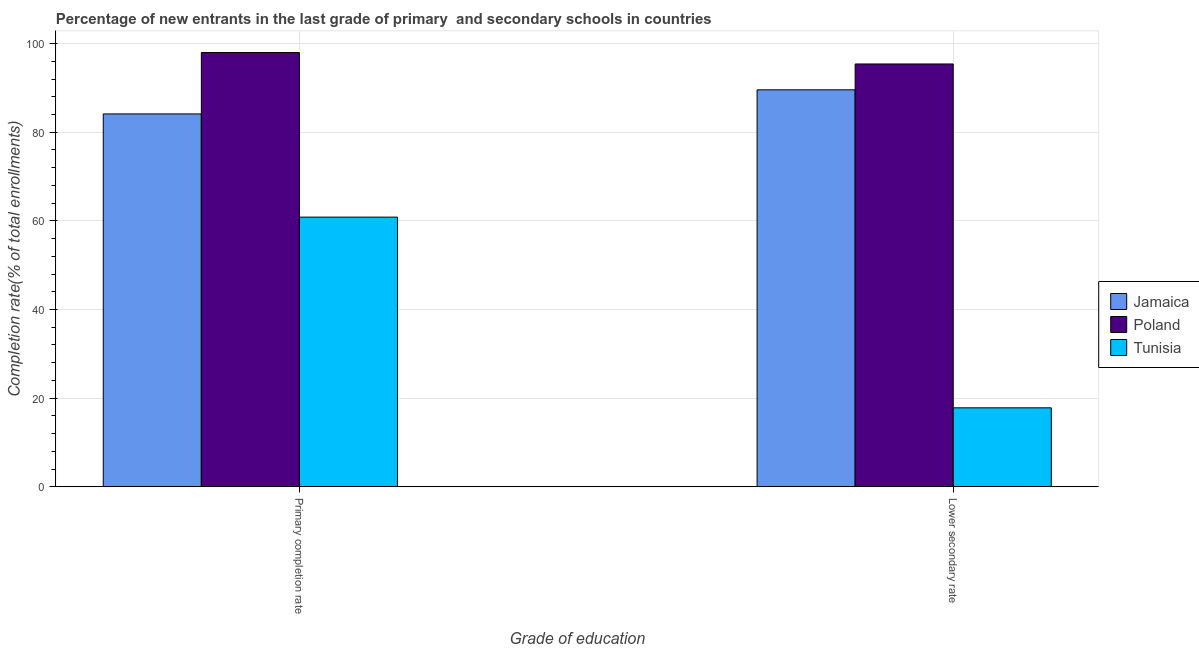Are the number of bars per tick equal to the number of legend labels?
Ensure brevity in your answer.  Yes. What is the label of the 2nd group of bars from the left?
Offer a very short reply. Lower secondary rate. What is the completion rate in secondary schools in Poland?
Offer a very short reply. 95.41. Across all countries, what is the maximum completion rate in secondary schools?
Your response must be concise. 95.41. Across all countries, what is the minimum completion rate in secondary schools?
Your answer should be very brief. 17.81. In which country was the completion rate in primary schools minimum?
Offer a very short reply. Tunisia. What is the total completion rate in secondary schools in the graph?
Your answer should be compact. 202.79. What is the difference between the completion rate in primary schools in Tunisia and that in Jamaica?
Give a very brief answer. -23.29. What is the difference between the completion rate in secondary schools in Jamaica and the completion rate in primary schools in Poland?
Offer a terse response. -8.41. What is the average completion rate in primary schools per country?
Provide a succinct answer. 80.99. What is the difference between the completion rate in secondary schools and completion rate in primary schools in Tunisia?
Make the answer very short. -43.04. In how many countries, is the completion rate in secondary schools greater than 16 %?
Your answer should be very brief. 3. What is the ratio of the completion rate in primary schools in Poland to that in Tunisia?
Offer a terse response. 1.61. Is the completion rate in secondary schools in Jamaica less than that in Poland?
Offer a terse response. Yes. What does the 3rd bar from the right in Primary completion rate represents?
Provide a succinct answer. Jamaica. How many bars are there?
Give a very brief answer. 6. How many countries are there in the graph?
Provide a short and direct response. 3. What is the difference between two consecutive major ticks on the Y-axis?
Make the answer very short. 20. Are the values on the major ticks of Y-axis written in scientific E-notation?
Keep it short and to the point. No. Does the graph contain any zero values?
Offer a terse response. No. Where does the legend appear in the graph?
Offer a terse response. Center right. How many legend labels are there?
Keep it short and to the point. 3. What is the title of the graph?
Your answer should be very brief. Percentage of new entrants in the last grade of primary  and secondary schools in countries. Does "Vietnam" appear as one of the legend labels in the graph?
Ensure brevity in your answer.  No. What is the label or title of the X-axis?
Provide a short and direct response. Grade of education. What is the label or title of the Y-axis?
Offer a terse response. Completion rate(% of total enrollments). What is the Completion rate(% of total enrollments) in Jamaica in Primary completion rate?
Your answer should be very brief. 84.13. What is the Completion rate(% of total enrollments) of Poland in Primary completion rate?
Your answer should be compact. 97.99. What is the Completion rate(% of total enrollments) in Tunisia in Primary completion rate?
Your answer should be very brief. 60.84. What is the Completion rate(% of total enrollments) in Jamaica in Lower secondary rate?
Your answer should be very brief. 89.58. What is the Completion rate(% of total enrollments) in Poland in Lower secondary rate?
Your answer should be compact. 95.41. What is the Completion rate(% of total enrollments) in Tunisia in Lower secondary rate?
Your response must be concise. 17.81. Across all Grade of education, what is the maximum Completion rate(% of total enrollments) in Jamaica?
Keep it short and to the point. 89.58. Across all Grade of education, what is the maximum Completion rate(% of total enrollments) in Poland?
Ensure brevity in your answer.  97.99. Across all Grade of education, what is the maximum Completion rate(% of total enrollments) of Tunisia?
Make the answer very short. 60.84. Across all Grade of education, what is the minimum Completion rate(% of total enrollments) of Jamaica?
Your answer should be very brief. 84.13. Across all Grade of education, what is the minimum Completion rate(% of total enrollments) of Poland?
Offer a terse response. 95.41. Across all Grade of education, what is the minimum Completion rate(% of total enrollments) in Tunisia?
Provide a short and direct response. 17.81. What is the total Completion rate(% of total enrollments) of Jamaica in the graph?
Offer a terse response. 173.71. What is the total Completion rate(% of total enrollments) in Poland in the graph?
Make the answer very short. 193.4. What is the total Completion rate(% of total enrollments) of Tunisia in the graph?
Your answer should be compact. 78.65. What is the difference between the Completion rate(% of total enrollments) of Jamaica in Primary completion rate and that in Lower secondary rate?
Offer a terse response. -5.44. What is the difference between the Completion rate(% of total enrollments) in Poland in Primary completion rate and that in Lower secondary rate?
Offer a very short reply. 2.58. What is the difference between the Completion rate(% of total enrollments) of Tunisia in Primary completion rate and that in Lower secondary rate?
Make the answer very short. 43.04. What is the difference between the Completion rate(% of total enrollments) in Jamaica in Primary completion rate and the Completion rate(% of total enrollments) in Poland in Lower secondary rate?
Provide a succinct answer. -11.27. What is the difference between the Completion rate(% of total enrollments) of Jamaica in Primary completion rate and the Completion rate(% of total enrollments) of Tunisia in Lower secondary rate?
Ensure brevity in your answer.  66.33. What is the difference between the Completion rate(% of total enrollments) in Poland in Primary completion rate and the Completion rate(% of total enrollments) in Tunisia in Lower secondary rate?
Offer a very short reply. 80.18. What is the average Completion rate(% of total enrollments) in Jamaica per Grade of education?
Offer a terse response. 86.86. What is the average Completion rate(% of total enrollments) in Poland per Grade of education?
Keep it short and to the point. 96.7. What is the average Completion rate(% of total enrollments) in Tunisia per Grade of education?
Your response must be concise. 39.33. What is the difference between the Completion rate(% of total enrollments) of Jamaica and Completion rate(% of total enrollments) of Poland in Primary completion rate?
Give a very brief answer. -13.85. What is the difference between the Completion rate(% of total enrollments) of Jamaica and Completion rate(% of total enrollments) of Tunisia in Primary completion rate?
Your response must be concise. 23.29. What is the difference between the Completion rate(% of total enrollments) in Poland and Completion rate(% of total enrollments) in Tunisia in Primary completion rate?
Your response must be concise. 37.15. What is the difference between the Completion rate(% of total enrollments) in Jamaica and Completion rate(% of total enrollments) in Poland in Lower secondary rate?
Your answer should be very brief. -5.83. What is the difference between the Completion rate(% of total enrollments) in Jamaica and Completion rate(% of total enrollments) in Tunisia in Lower secondary rate?
Provide a short and direct response. 71.77. What is the difference between the Completion rate(% of total enrollments) of Poland and Completion rate(% of total enrollments) of Tunisia in Lower secondary rate?
Provide a succinct answer. 77.6. What is the ratio of the Completion rate(% of total enrollments) of Jamaica in Primary completion rate to that in Lower secondary rate?
Make the answer very short. 0.94. What is the ratio of the Completion rate(% of total enrollments) of Poland in Primary completion rate to that in Lower secondary rate?
Keep it short and to the point. 1.03. What is the ratio of the Completion rate(% of total enrollments) in Tunisia in Primary completion rate to that in Lower secondary rate?
Your response must be concise. 3.42. What is the difference between the highest and the second highest Completion rate(% of total enrollments) in Jamaica?
Keep it short and to the point. 5.44. What is the difference between the highest and the second highest Completion rate(% of total enrollments) of Poland?
Provide a succinct answer. 2.58. What is the difference between the highest and the second highest Completion rate(% of total enrollments) in Tunisia?
Your answer should be compact. 43.04. What is the difference between the highest and the lowest Completion rate(% of total enrollments) of Jamaica?
Provide a succinct answer. 5.44. What is the difference between the highest and the lowest Completion rate(% of total enrollments) of Poland?
Ensure brevity in your answer.  2.58. What is the difference between the highest and the lowest Completion rate(% of total enrollments) of Tunisia?
Your answer should be very brief. 43.04. 